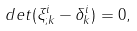Convert formula to latex. <formula><loc_0><loc_0><loc_500><loc_500>d e t ( \xi ^ { i } _ { ; k } - \delta ^ { i } _ { k } ) = 0 ,</formula> 